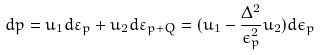Convert formula to latex. <formula><loc_0><loc_0><loc_500><loc_500>d { p } = { u } _ { 1 } d \varepsilon _ { p } + { u } _ { 2 } d \varepsilon _ { p + Q } = ( { u } _ { 1 } - \frac { \Delta ^ { 2 } } { \epsilon _ { p } ^ { 2 } } { u } _ { 2 } ) d \epsilon _ { p }</formula> 